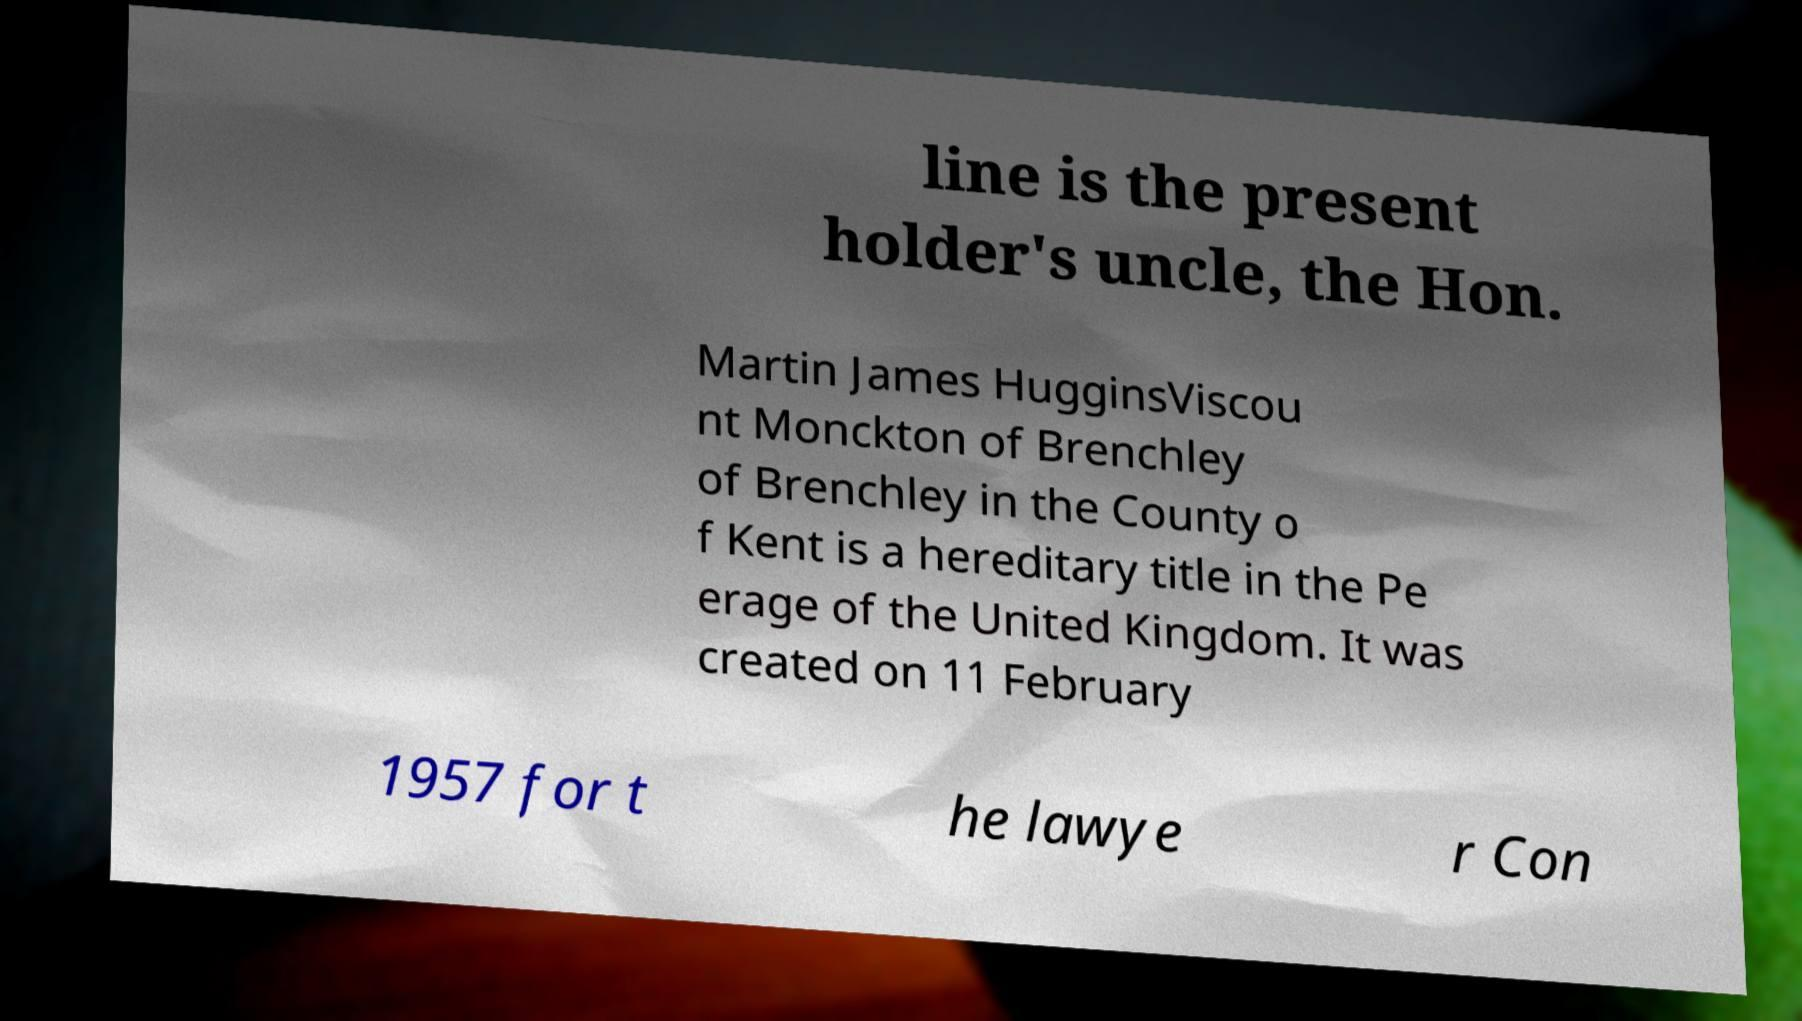Could you assist in decoding the text presented in this image and type it out clearly? line is the present holder's uncle, the Hon. Martin James HugginsViscou nt Monckton of Brenchley of Brenchley in the County o f Kent is a hereditary title in the Pe erage of the United Kingdom. It was created on 11 February 1957 for t he lawye r Con 